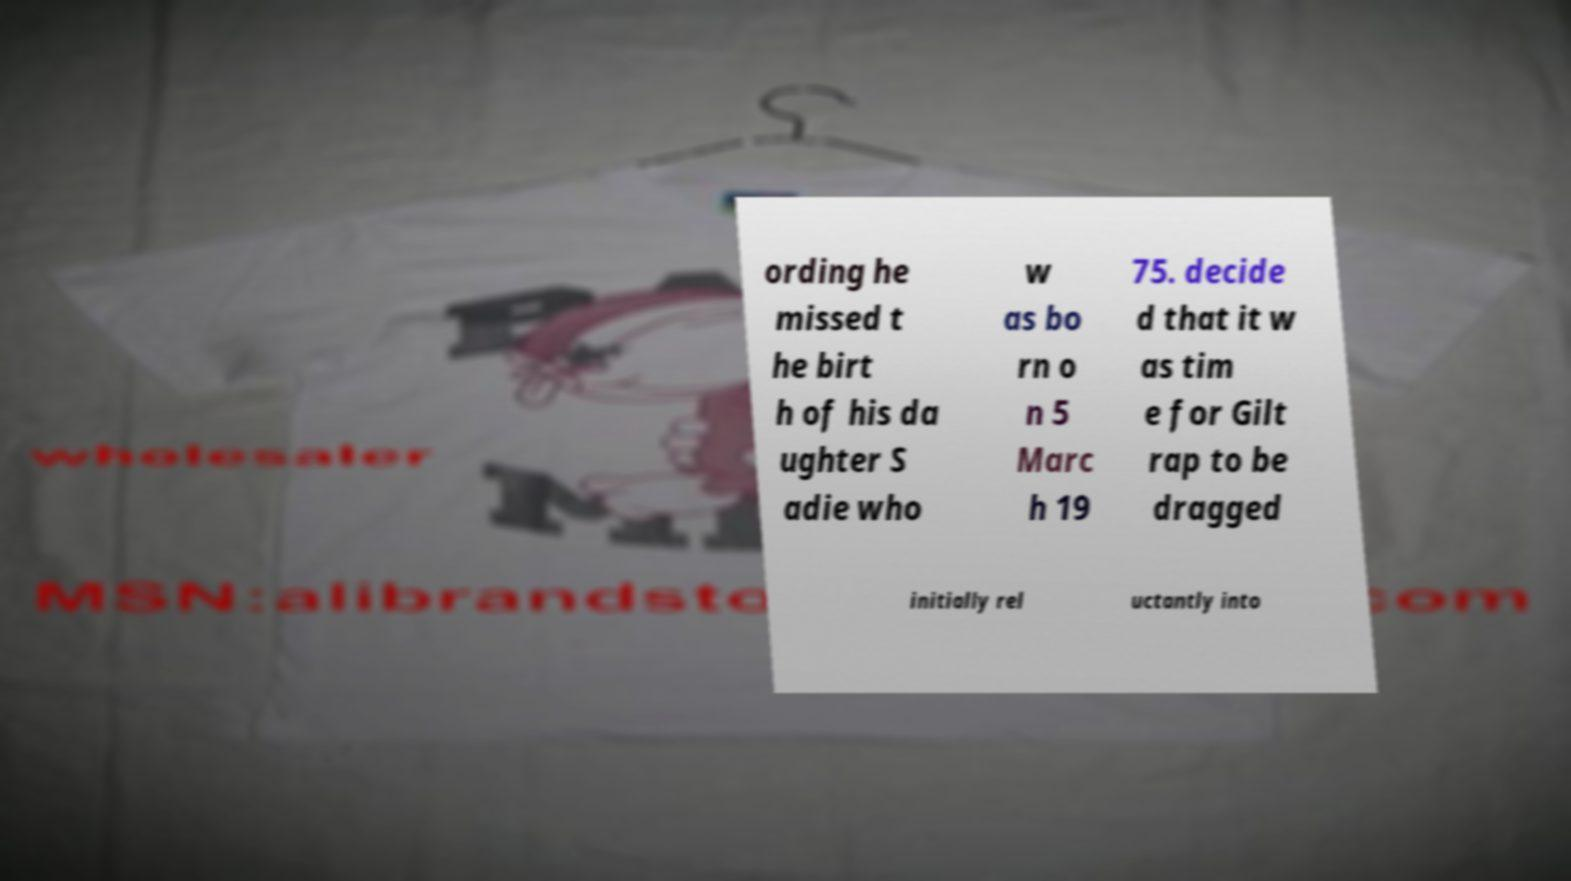Please identify and transcribe the text found in this image. ording he missed t he birt h of his da ughter S adie who w as bo rn o n 5 Marc h 19 75. decide d that it w as tim e for Gilt rap to be dragged initially rel uctantly into 